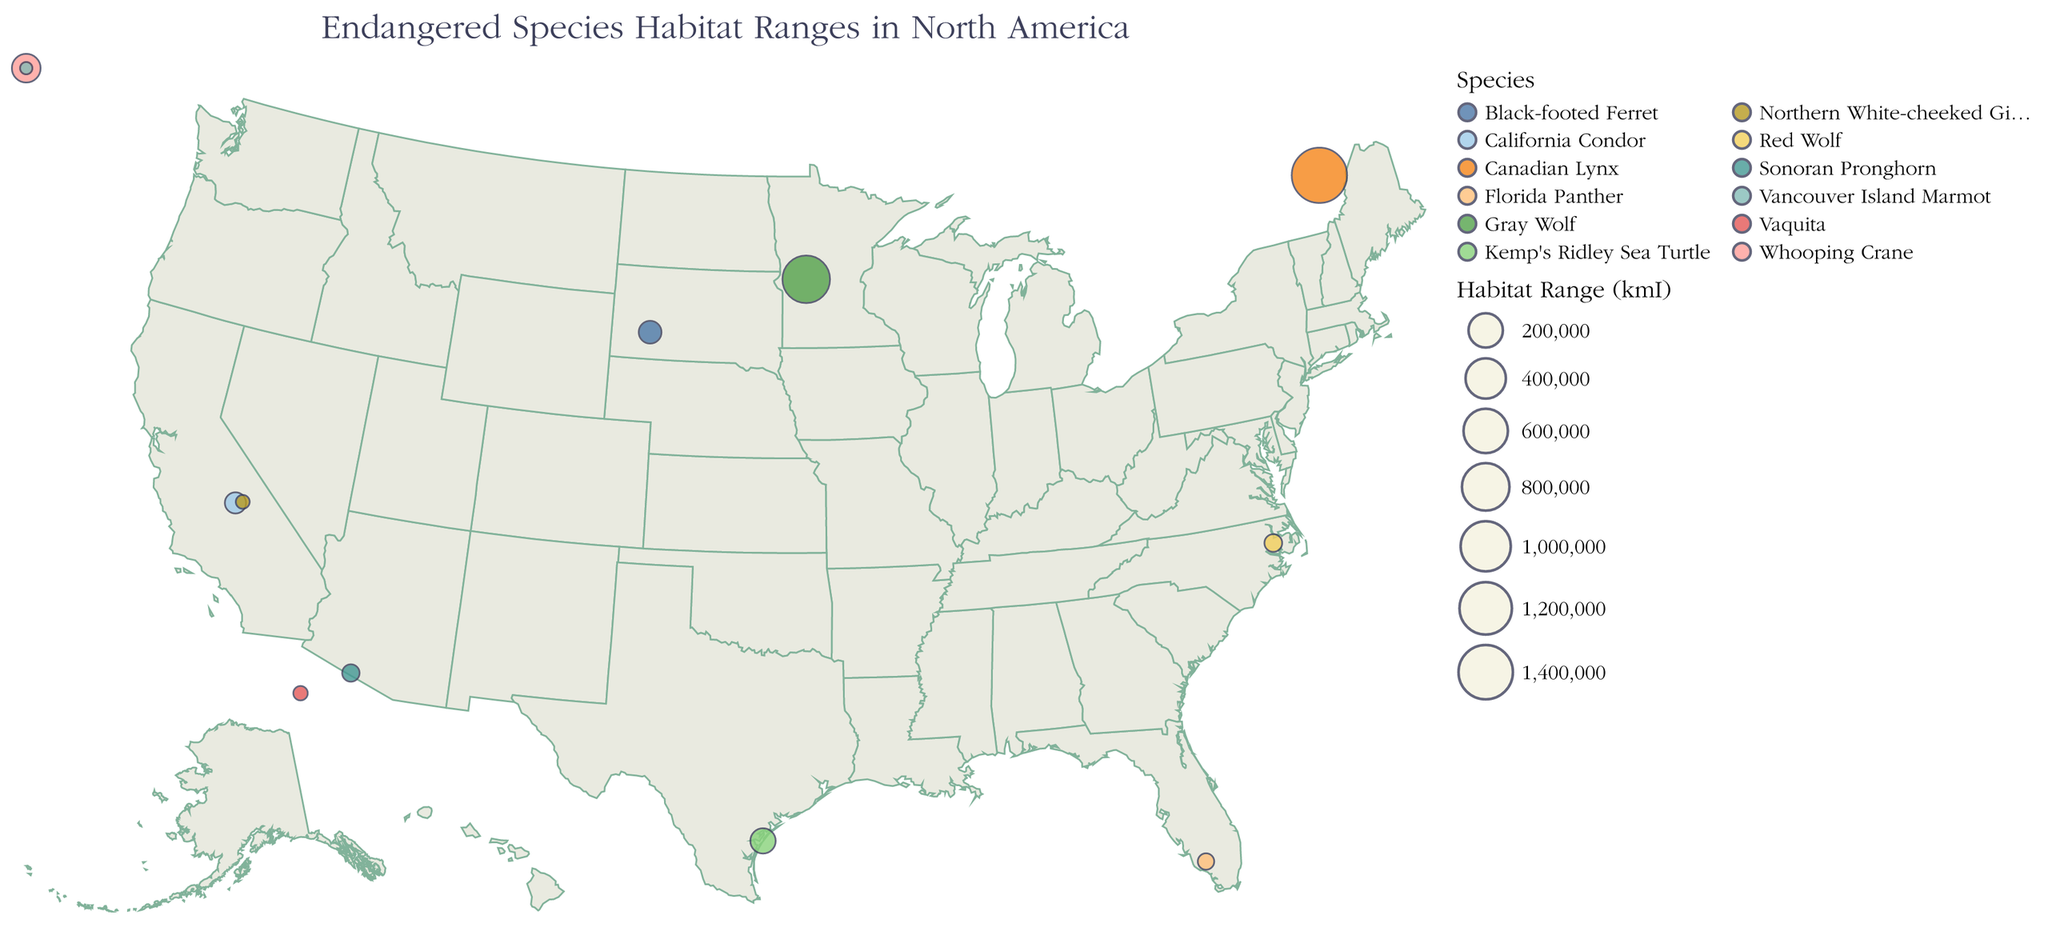what is the title of the plot? The title is displayed at the top of the figure in large font. It reads "Endangered Species Habitat Ranges in North America".
Answer: Endangered Species Habitat Ranges in North America How many species are represented in the plot? By counting the unique species names listed in the legend or in the data points, we see there are 12 species.
Answer: 12 Which species has the largest habitat range? By observing the size of the circles on the map or referring to the tooltip information, we can see the Canadian Lynx has the largest habitat range of 1,500,000 km².
Answer: Canadian Lynx Which species has the smallest habitat range? By noting the smallest circle on the map and checking the tooltip information, we find that the Vancouver Island Marmot has the smallest habitat range of 500 km².
Answer: Vancouver Island Marmot What is the habitat range of the Florida Panther? Hovering over the circle representing the Florida Panther or checking for its data point, we can find its habitat range, which is 5,000 km².
Answer: 5,000 km² What are the coordinates (latitude and longitude) of the Vaquita? The position of the Vaquita on the map or in the data points gives us the coordinates, which are Latitude: 31.0254 and Longitude: -114.5228.
Answer: 31.0254, -114.5228 Which two species' habitat ranges are closest in size? Comparing the sizes of the circles or the data points, the California Condor (21,000 km²) and the Black-footed Ferret (30,000 km²) have the closest habitat ranges with a difference of 9,000 km².
Answer: California Condor and Black-footed Ferret Which regions of North America have the highest concentration of endangered species in terms of latitude and longitude? Observing clusters of circles on the map, we can see the regions around southern U.S. and northern Mexico, as well as areas around the northern U.S. and southern Canada, have higher concentrations of endangered species.
Answer: Southern U.S. and northern Mexico, northern U.S. and southern Canada How many species have a habitat range greater than 100,000 km²? By examining the tooltip or data, it is clear that there are two species with habitat ranges greater than 100,000 km²: the Gray Wolf and the Canadian Lynx.
Answer: Two Which species are located in the same region around Latitude 36.5 and Longitude -118.5? Looking at the map and the data points, the California Condor and Northern White-cheeked Gibbon are both found around Latitude 36.5 and Longitude -118.5.
Answer: California Condor and Northern White-cheeked Gibbon 